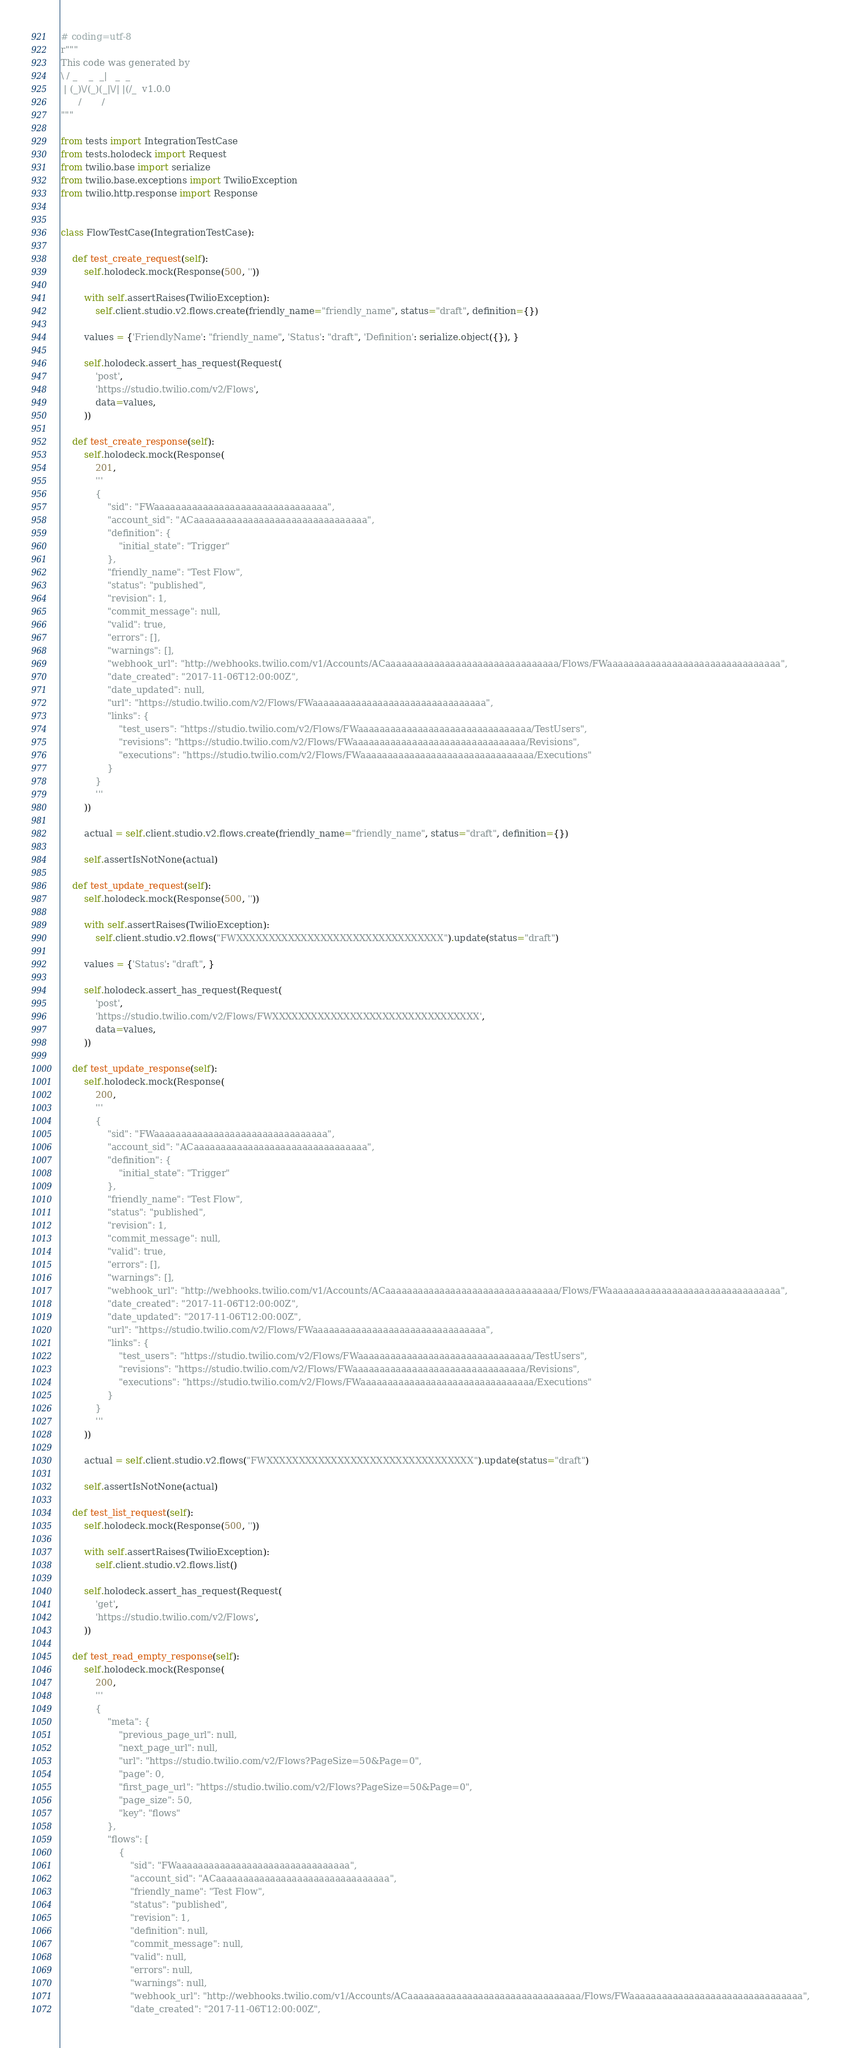Convert code to text. <code><loc_0><loc_0><loc_500><loc_500><_Python_># coding=utf-8
r"""
This code was generated by
\ / _    _  _|   _  _
 | (_)\/(_)(_|\/| |(/_  v1.0.0
      /       /
"""

from tests import IntegrationTestCase
from tests.holodeck import Request
from twilio.base import serialize
from twilio.base.exceptions import TwilioException
from twilio.http.response import Response


class FlowTestCase(IntegrationTestCase):

    def test_create_request(self):
        self.holodeck.mock(Response(500, ''))

        with self.assertRaises(TwilioException):
            self.client.studio.v2.flows.create(friendly_name="friendly_name", status="draft", definition={})

        values = {'FriendlyName': "friendly_name", 'Status': "draft", 'Definition': serialize.object({}), }

        self.holodeck.assert_has_request(Request(
            'post',
            'https://studio.twilio.com/v2/Flows',
            data=values,
        ))

    def test_create_response(self):
        self.holodeck.mock(Response(
            201,
            '''
            {
                "sid": "FWaaaaaaaaaaaaaaaaaaaaaaaaaaaaaaaa",
                "account_sid": "ACaaaaaaaaaaaaaaaaaaaaaaaaaaaaaaaa",
                "definition": {
                    "initial_state": "Trigger"
                },
                "friendly_name": "Test Flow",
                "status": "published",
                "revision": 1,
                "commit_message": null,
                "valid": true,
                "errors": [],
                "warnings": [],
                "webhook_url": "http://webhooks.twilio.com/v1/Accounts/ACaaaaaaaaaaaaaaaaaaaaaaaaaaaaaaaa/Flows/FWaaaaaaaaaaaaaaaaaaaaaaaaaaaaaaaa",
                "date_created": "2017-11-06T12:00:00Z",
                "date_updated": null,
                "url": "https://studio.twilio.com/v2/Flows/FWaaaaaaaaaaaaaaaaaaaaaaaaaaaaaaaa",
                "links": {
                    "test_users": "https://studio.twilio.com/v2/Flows/FWaaaaaaaaaaaaaaaaaaaaaaaaaaaaaaaa/TestUsers",
                    "revisions": "https://studio.twilio.com/v2/Flows/FWaaaaaaaaaaaaaaaaaaaaaaaaaaaaaaaa/Revisions",
                    "executions": "https://studio.twilio.com/v2/Flows/FWaaaaaaaaaaaaaaaaaaaaaaaaaaaaaaaa/Executions"
                }
            }
            '''
        ))

        actual = self.client.studio.v2.flows.create(friendly_name="friendly_name", status="draft", definition={})

        self.assertIsNotNone(actual)

    def test_update_request(self):
        self.holodeck.mock(Response(500, ''))

        with self.assertRaises(TwilioException):
            self.client.studio.v2.flows("FWXXXXXXXXXXXXXXXXXXXXXXXXXXXXXXXX").update(status="draft")

        values = {'Status': "draft", }

        self.holodeck.assert_has_request(Request(
            'post',
            'https://studio.twilio.com/v2/Flows/FWXXXXXXXXXXXXXXXXXXXXXXXXXXXXXXXX',
            data=values,
        ))

    def test_update_response(self):
        self.holodeck.mock(Response(
            200,
            '''
            {
                "sid": "FWaaaaaaaaaaaaaaaaaaaaaaaaaaaaaaaa",
                "account_sid": "ACaaaaaaaaaaaaaaaaaaaaaaaaaaaaaaaa",
                "definition": {
                    "initial_state": "Trigger"
                },
                "friendly_name": "Test Flow",
                "status": "published",
                "revision": 1,
                "commit_message": null,
                "valid": true,
                "errors": [],
                "warnings": [],
                "webhook_url": "http://webhooks.twilio.com/v1/Accounts/ACaaaaaaaaaaaaaaaaaaaaaaaaaaaaaaaa/Flows/FWaaaaaaaaaaaaaaaaaaaaaaaaaaaaaaaa",
                "date_created": "2017-11-06T12:00:00Z",
                "date_updated": "2017-11-06T12:00:00Z",
                "url": "https://studio.twilio.com/v2/Flows/FWaaaaaaaaaaaaaaaaaaaaaaaaaaaaaaaa",
                "links": {
                    "test_users": "https://studio.twilio.com/v2/Flows/FWaaaaaaaaaaaaaaaaaaaaaaaaaaaaaaaa/TestUsers",
                    "revisions": "https://studio.twilio.com/v2/Flows/FWaaaaaaaaaaaaaaaaaaaaaaaaaaaaaaaa/Revisions",
                    "executions": "https://studio.twilio.com/v2/Flows/FWaaaaaaaaaaaaaaaaaaaaaaaaaaaaaaaa/Executions"
                }
            }
            '''
        ))

        actual = self.client.studio.v2.flows("FWXXXXXXXXXXXXXXXXXXXXXXXXXXXXXXXX").update(status="draft")

        self.assertIsNotNone(actual)

    def test_list_request(self):
        self.holodeck.mock(Response(500, ''))

        with self.assertRaises(TwilioException):
            self.client.studio.v2.flows.list()

        self.holodeck.assert_has_request(Request(
            'get',
            'https://studio.twilio.com/v2/Flows',
        ))

    def test_read_empty_response(self):
        self.holodeck.mock(Response(
            200,
            '''
            {
                "meta": {
                    "previous_page_url": null,
                    "next_page_url": null,
                    "url": "https://studio.twilio.com/v2/Flows?PageSize=50&Page=0",
                    "page": 0,
                    "first_page_url": "https://studio.twilio.com/v2/Flows?PageSize=50&Page=0",
                    "page_size": 50,
                    "key": "flows"
                },
                "flows": [
                    {
                        "sid": "FWaaaaaaaaaaaaaaaaaaaaaaaaaaaaaaaa",
                        "account_sid": "ACaaaaaaaaaaaaaaaaaaaaaaaaaaaaaaaa",
                        "friendly_name": "Test Flow",
                        "status": "published",
                        "revision": 1,
                        "definition": null,
                        "commit_message": null,
                        "valid": null,
                        "errors": null,
                        "warnings": null,
                        "webhook_url": "http://webhooks.twilio.com/v1/Accounts/ACaaaaaaaaaaaaaaaaaaaaaaaaaaaaaaaa/Flows/FWaaaaaaaaaaaaaaaaaaaaaaaaaaaaaaaa",
                        "date_created": "2017-11-06T12:00:00Z",</code> 